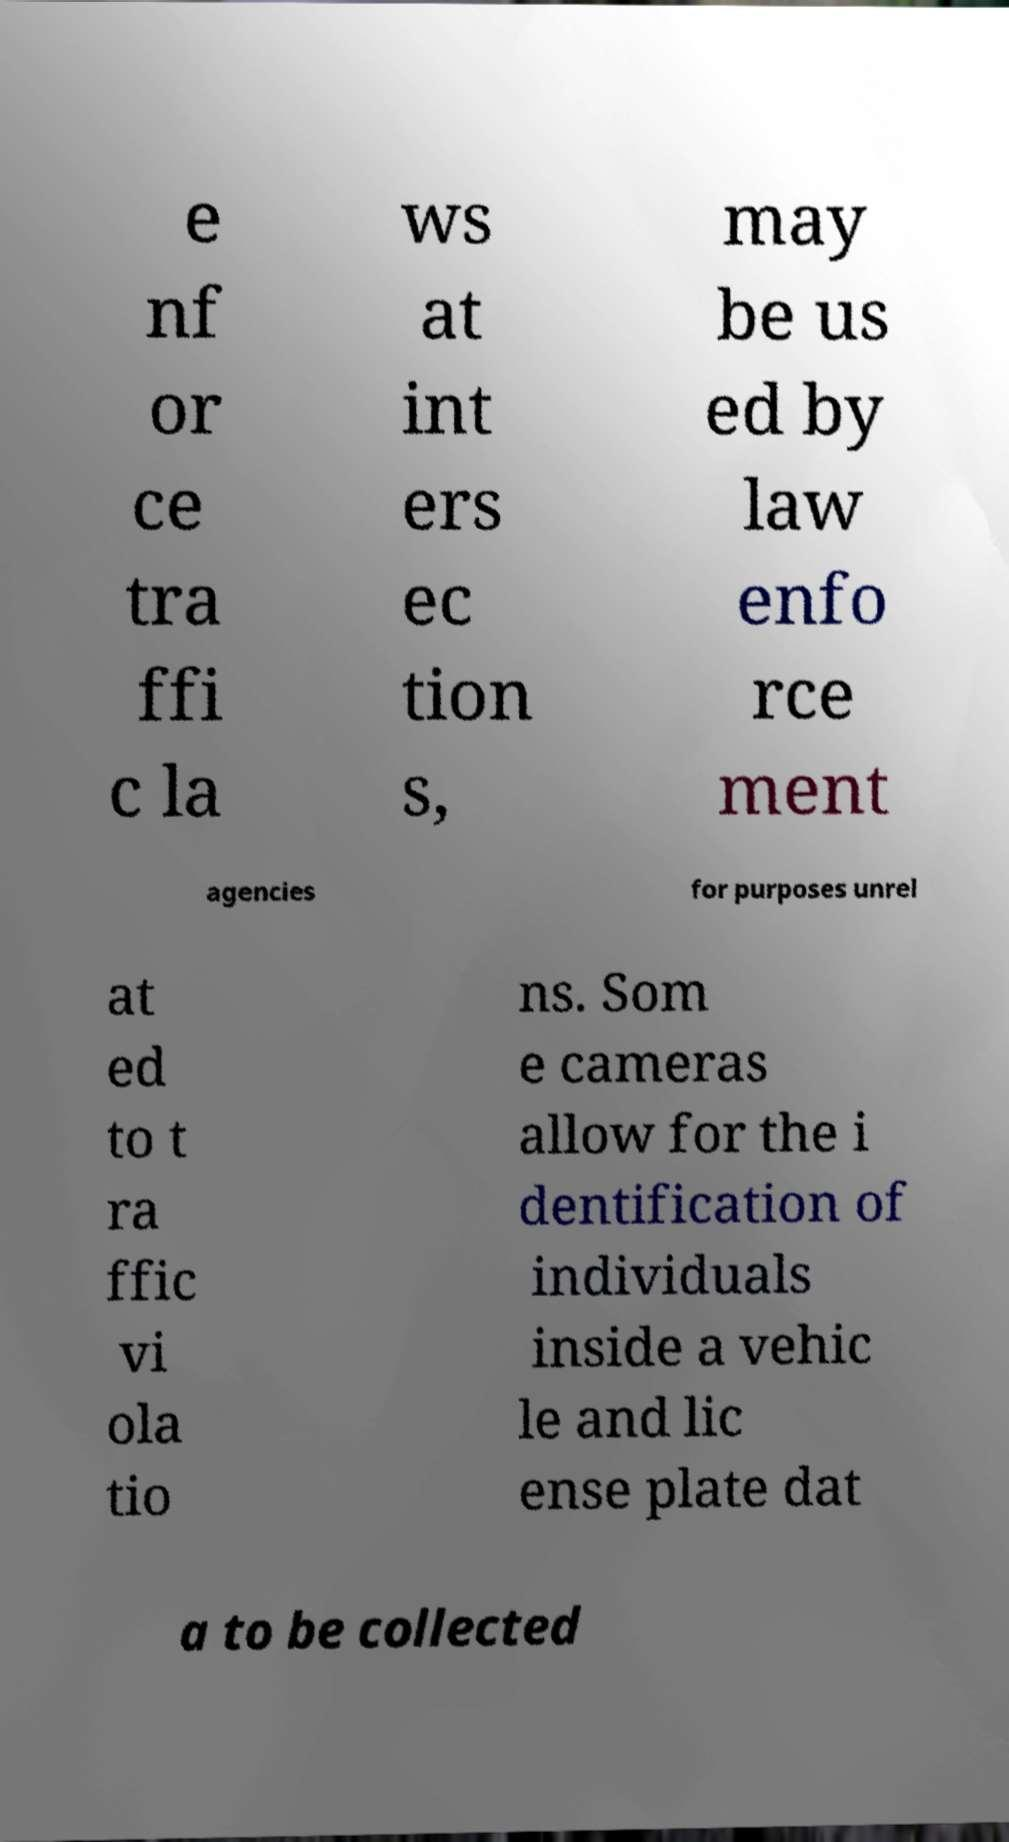Could you extract and type out the text from this image? e nf or ce tra ffi c la ws at int ers ec tion s, may be us ed by law enfo rce ment agencies for purposes unrel at ed to t ra ffic vi ola tio ns. Som e cameras allow for the i dentification of individuals inside a vehic le and lic ense plate dat a to be collected 